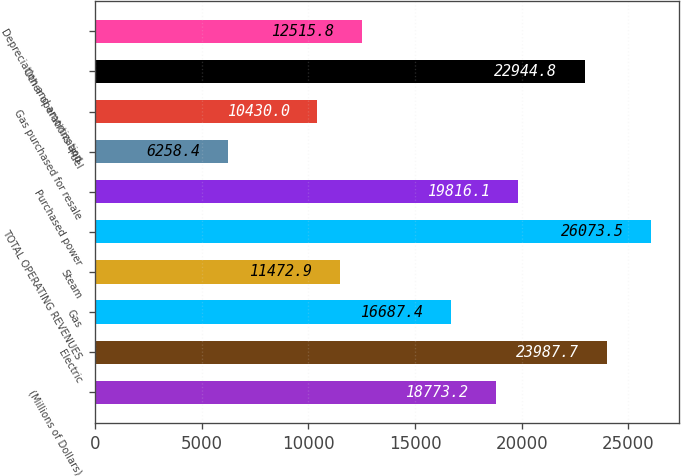<chart> <loc_0><loc_0><loc_500><loc_500><bar_chart><fcel>(Millions of Dollars)<fcel>Electric<fcel>Gas<fcel>Steam<fcel>TOTAL OPERATING REVENUES<fcel>Purchased power<fcel>Fuel<fcel>Gas purchased for resale<fcel>Other operations and<fcel>Depreciation and amortization<nl><fcel>18773.2<fcel>23987.7<fcel>16687.4<fcel>11472.9<fcel>26073.5<fcel>19816.1<fcel>6258.4<fcel>10430<fcel>22944.8<fcel>12515.8<nl></chart> 